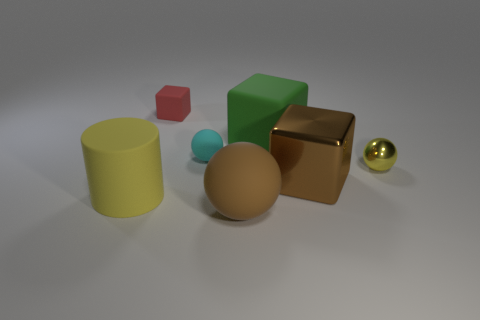Add 2 big blue spheres. How many objects exist? 9 Subtract all blocks. How many objects are left? 4 Subtract all rubber things. Subtract all brown shiny objects. How many objects are left? 1 Add 7 spheres. How many spheres are left? 10 Add 6 large purple blocks. How many large purple blocks exist? 6 Subtract 0 blue blocks. How many objects are left? 7 